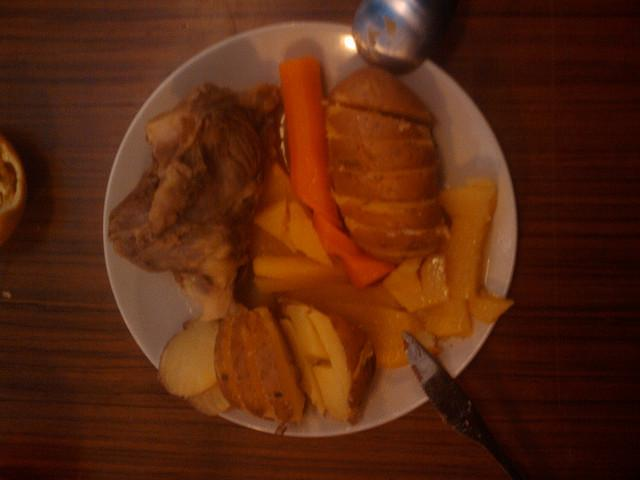What kind of vegetable is between the bread and the meat on top of the white plate? carrot 